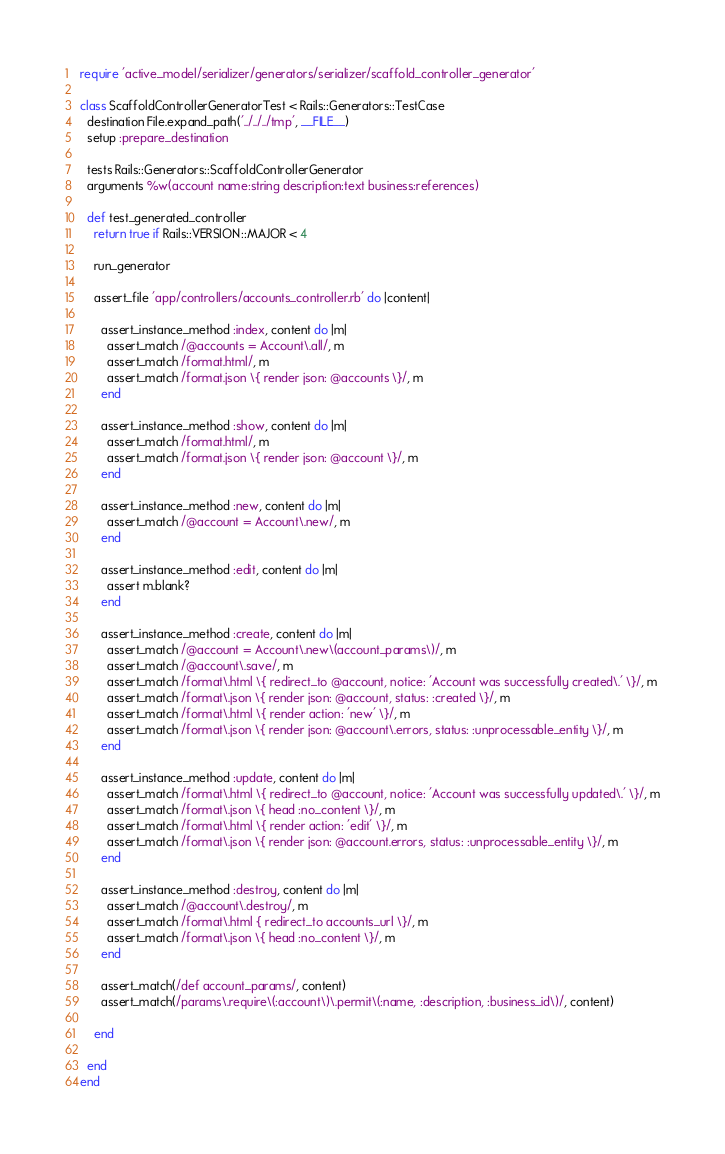<code> <loc_0><loc_0><loc_500><loc_500><_Ruby_>require 'active_model/serializer/generators/serializer/scaffold_controller_generator'

class ScaffoldControllerGeneratorTest < Rails::Generators::TestCase
  destination File.expand_path('../../../tmp', __FILE__)
  setup :prepare_destination

  tests Rails::Generators::ScaffoldControllerGenerator
  arguments %w(account name:string description:text business:references)

  def test_generated_controller
    return true if Rails::VERSION::MAJOR < 4

    run_generator

    assert_file 'app/controllers/accounts_controller.rb' do |content|
      
      assert_instance_method :index, content do |m|
        assert_match /@accounts = Account\.all/, m
        assert_match /format.html/, m
        assert_match /format.json \{ render json: @accounts \}/, m
      end

      assert_instance_method :show, content do |m|
        assert_match /format.html/, m
        assert_match /format.json \{ render json: @account \}/, m
      end

      assert_instance_method :new, content do |m|
        assert_match /@account = Account\.new/, m
      end

      assert_instance_method :edit, content do |m|
        assert m.blank?
      end

      assert_instance_method :create, content do |m|
        assert_match /@account = Account\.new\(account_params\)/, m
        assert_match /@account\.save/, m
        assert_match /format\.html \{ redirect_to @account, notice: 'Account was successfully created\.' \}/, m
        assert_match /format\.json \{ render json: @account, status: :created \}/, m
        assert_match /format\.html \{ render action: 'new' \}/, m
        assert_match /format\.json \{ render json: @account\.errors, status: :unprocessable_entity \}/, m
      end

      assert_instance_method :update, content do |m|
        assert_match /format\.html \{ redirect_to @account, notice: 'Account was successfully updated\.' \}/, m
        assert_match /format\.json \{ head :no_content \}/, m
        assert_match /format\.html \{ render action: 'edit' \}/, m
        assert_match /format\.json \{ render json: @account.errors, status: :unprocessable_entity \}/, m
      end

      assert_instance_method :destroy, content do |m|
        assert_match /@account\.destroy/, m
        assert_match /format\.html { redirect_to accounts_url \}/, m
        assert_match /format\.json \{ head :no_content \}/, m
      end

      assert_match(/def account_params/, content)
      assert_match(/params\.require\(:account\)\.permit\(:name, :description, :business_id\)/, content)

    end

  end
end
</code> 